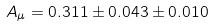Convert formula to latex. <formula><loc_0><loc_0><loc_500><loc_500>A _ { \mu } = 0 . 3 1 1 \pm 0 . 0 4 3 \pm 0 . 0 1 0</formula> 